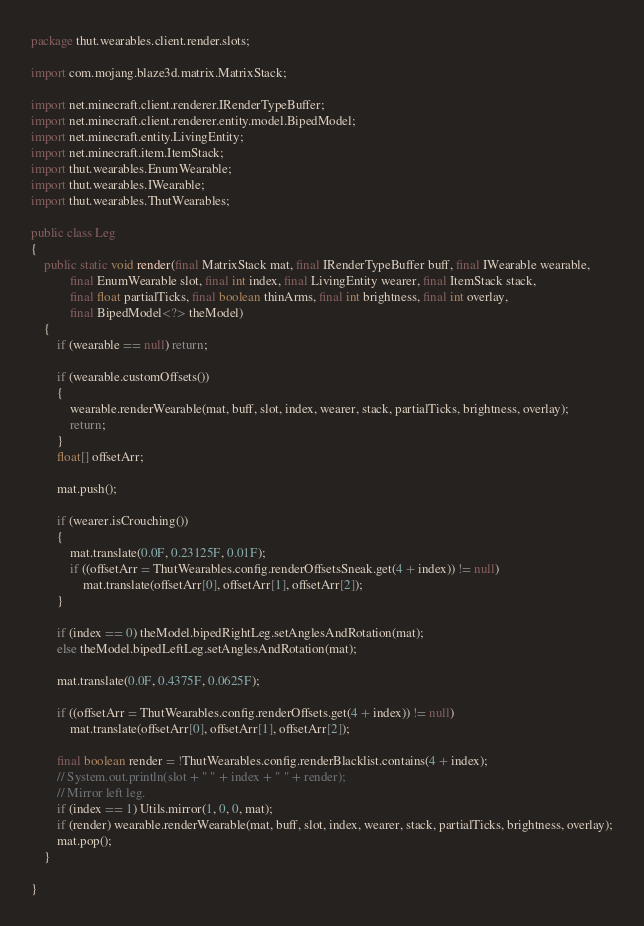<code> <loc_0><loc_0><loc_500><loc_500><_Java_>package thut.wearables.client.render.slots;

import com.mojang.blaze3d.matrix.MatrixStack;

import net.minecraft.client.renderer.IRenderTypeBuffer;
import net.minecraft.client.renderer.entity.model.BipedModel;
import net.minecraft.entity.LivingEntity;
import net.minecraft.item.ItemStack;
import thut.wearables.EnumWearable;
import thut.wearables.IWearable;
import thut.wearables.ThutWearables;

public class Leg
{
    public static void render(final MatrixStack mat, final IRenderTypeBuffer buff, final IWearable wearable,
            final EnumWearable slot, final int index, final LivingEntity wearer, final ItemStack stack,
            final float partialTicks, final boolean thinArms, final int brightness, final int overlay,
            final BipedModel<?> theModel)
    {
        if (wearable == null) return;

        if (wearable.customOffsets())
        {
            wearable.renderWearable(mat, buff, slot, index, wearer, stack, partialTicks, brightness, overlay);
            return;
        }
        float[] offsetArr;

        mat.push();

        if (wearer.isCrouching())
        {
            mat.translate(0.0F, 0.23125F, 0.01F);
            if ((offsetArr = ThutWearables.config.renderOffsetsSneak.get(4 + index)) != null)
                mat.translate(offsetArr[0], offsetArr[1], offsetArr[2]);
        }

        if (index == 0) theModel.bipedRightLeg.setAnglesAndRotation(mat);
        else theModel.bipedLeftLeg.setAnglesAndRotation(mat);

        mat.translate(0.0F, 0.4375F, 0.0625F);

        if ((offsetArr = ThutWearables.config.renderOffsets.get(4 + index)) != null)
            mat.translate(offsetArr[0], offsetArr[1], offsetArr[2]);

        final boolean render = !ThutWearables.config.renderBlacklist.contains(4 + index);
        // System.out.println(slot + " " + index + " " + render);
        // Mirror left leg.
        if (index == 1) Utils.mirror(1, 0, 0, mat);
        if (render) wearable.renderWearable(mat, buff, slot, index, wearer, stack, partialTicks, brightness, overlay);
        mat.pop();
    }

}
</code> 